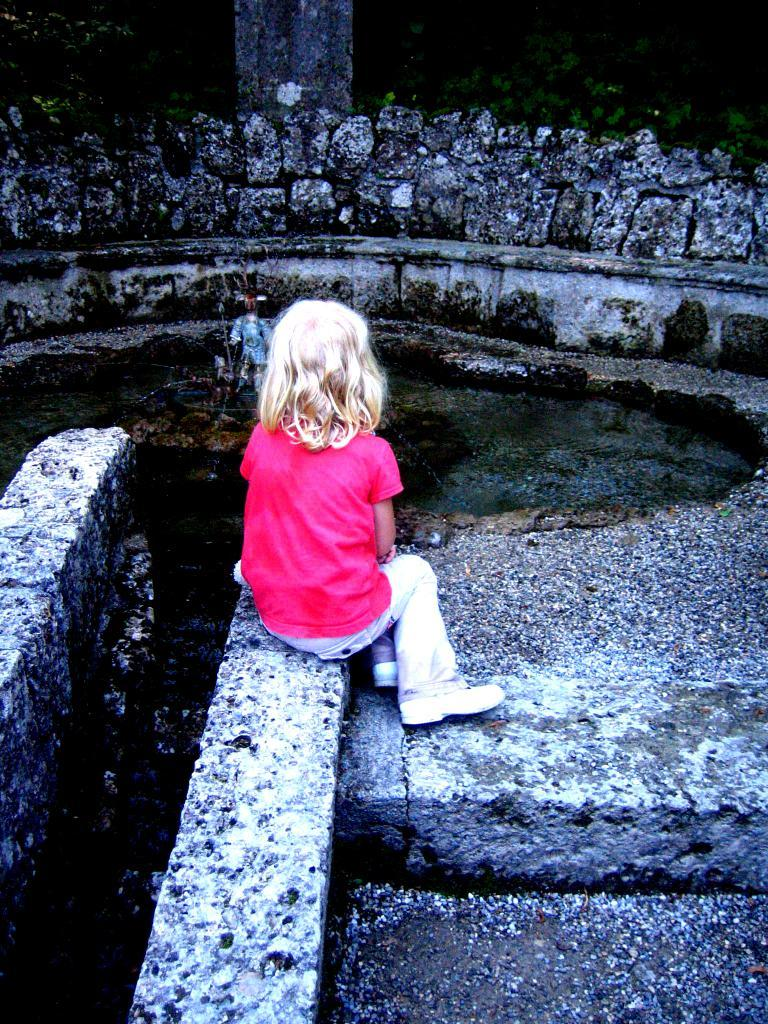What is the girl in the image doing? The girl is sitting on a wall in the image. What else can be seen in the image besides the girl? There are objects visible in the image. What type of vegetation is present at the top of the image? There are plants at the top of the image. What type of baseball twist can be seen in the image? There is no baseball or twist present in the image. Is there a bomb visible in the image? No, there is no bomb present in the image. 